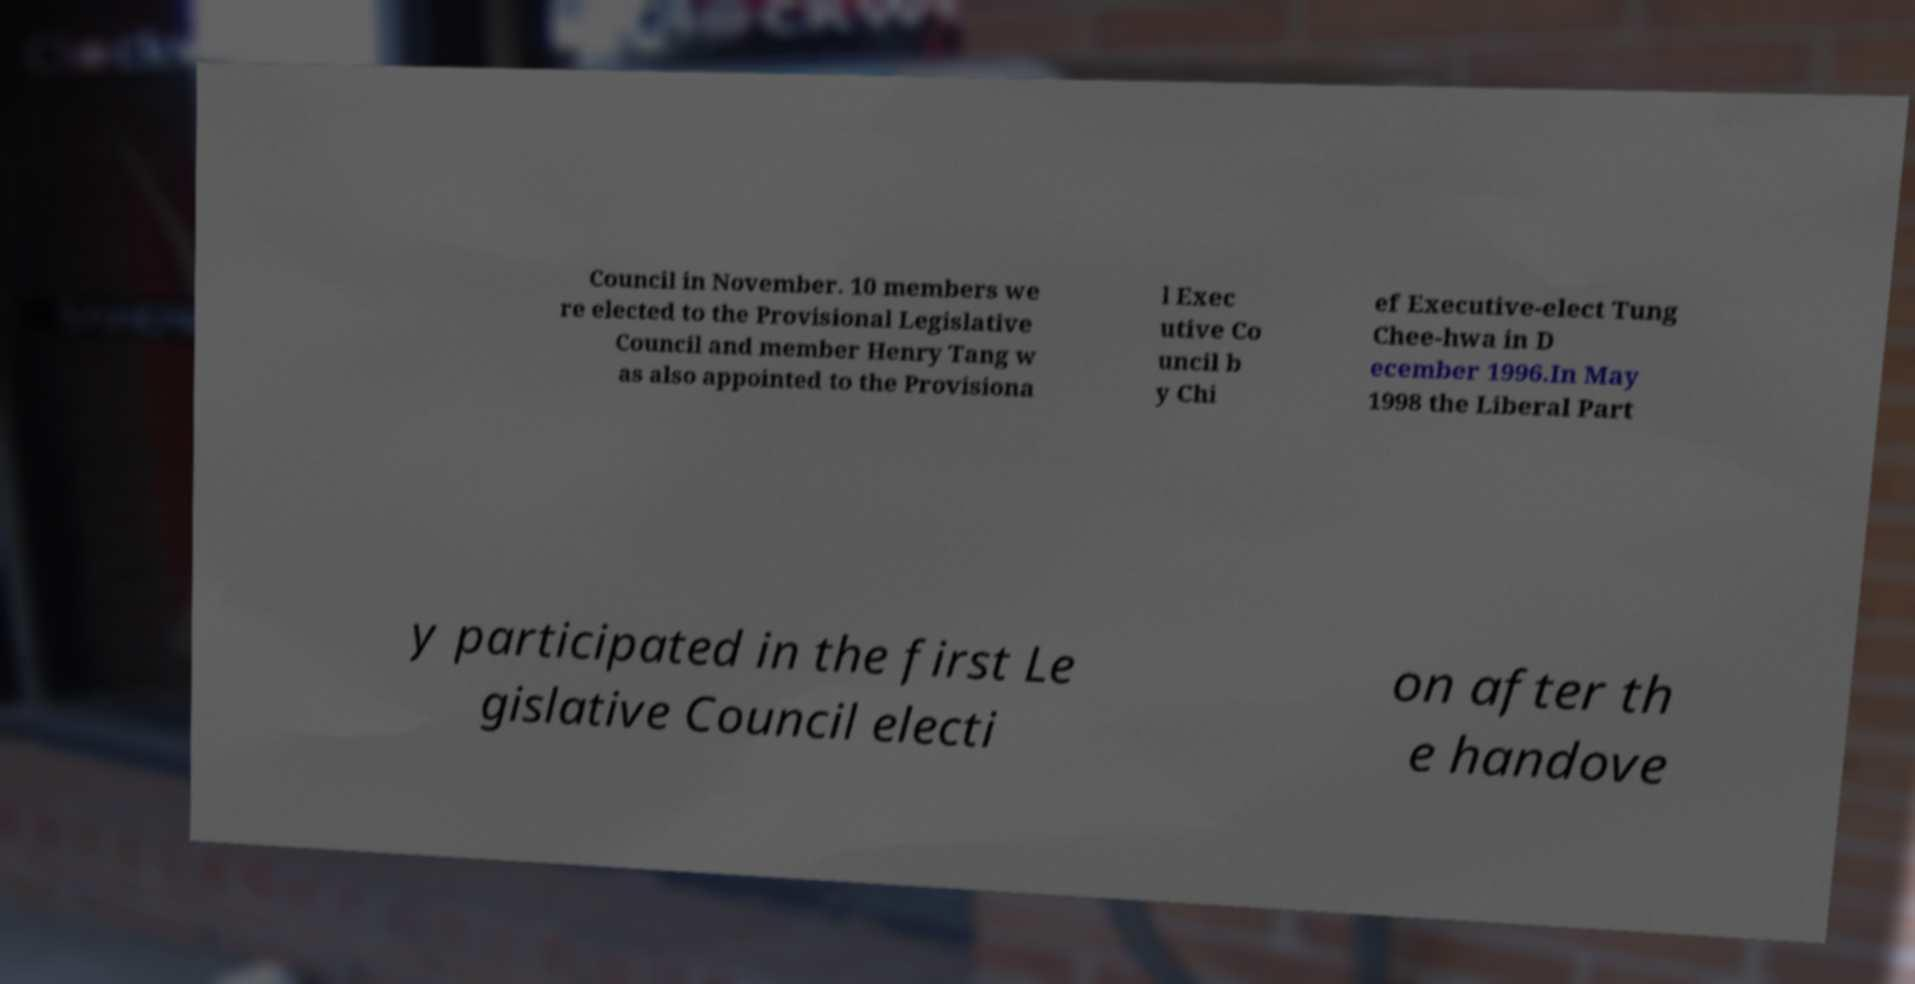Please identify and transcribe the text found in this image. Council in November. 10 members we re elected to the Provisional Legislative Council and member Henry Tang w as also appointed to the Provisiona l Exec utive Co uncil b y Chi ef Executive-elect Tung Chee-hwa in D ecember 1996.In May 1998 the Liberal Part y participated in the first Le gislative Council electi on after th e handove 